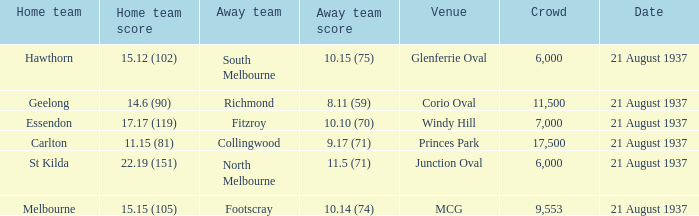Where does South Melbourne play? Glenferrie Oval. 